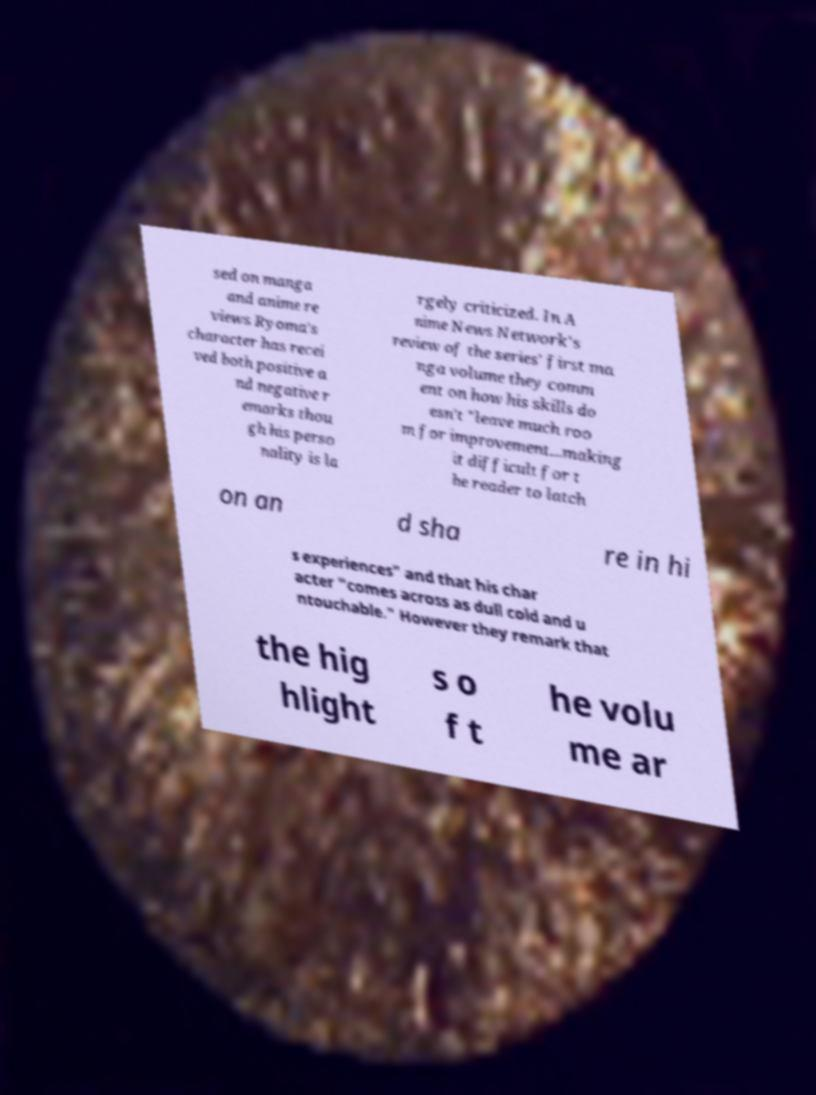Can you read and provide the text displayed in the image?This photo seems to have some interesting text. Can you extract and type it out for me? sed on manga and anime re views Ryoma's character has recei ved both positive a nd negative r emarks thou gh his perso nality is la rgely criticized. In A nime News Network's review of the series' first ma nga volume they comm ent on how his skills do esn't "leave much roo m for improvement...making it difficult for t he reader to latch on an d sha re in hi s experiences" and that his char acter "comes across as dull cold and u ntouchable." However they remark that the hig hlight s o f t he volu me ar 